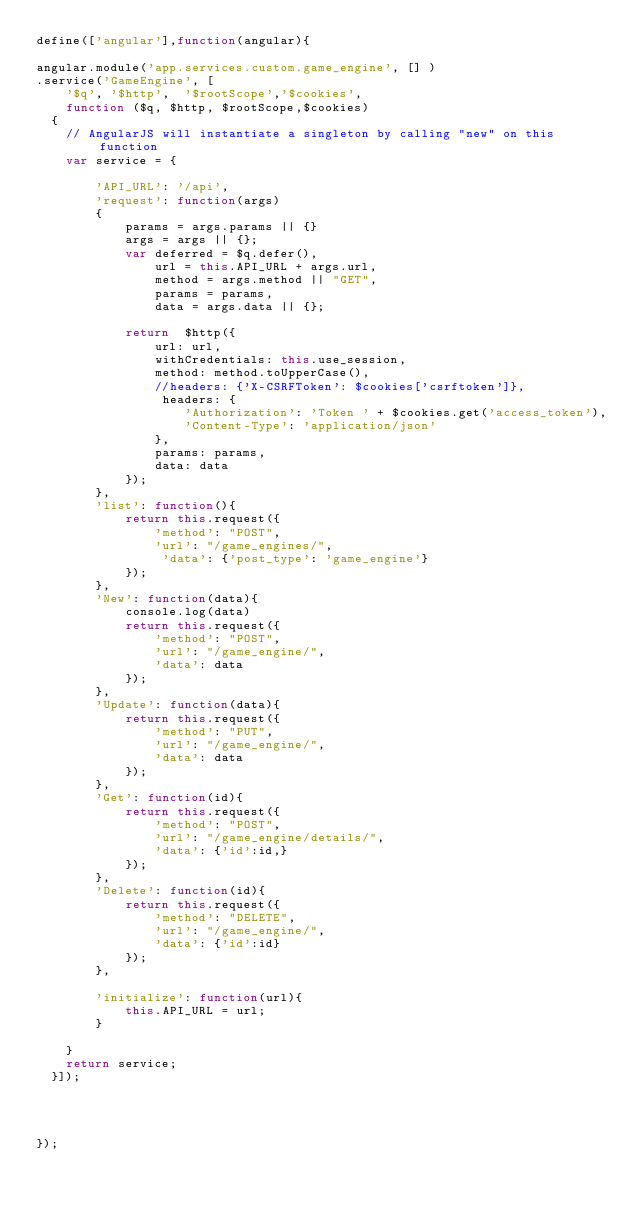Convert code to text. <code><loc_0><loc_0><loc_500><loc_500><_JavaScript_>define(['angular'],function(angular){

angular.module('app.services.custom.game_engine', [] )
.service('GameEngine', [ 
    '$q', '$http',  '$rootScope','$cookies', 
    function ($q, $http, $rootScope,$cookies) 
  {
    // AngularJS will instantiate a singleton by calling "new" on this function
    var service = {
        
        'API_URL': '/api',
        'request': function(args) 
        {
            params = args.params || {}
            args = args || {};
            var deferred = $q.defer(),
                url = this.API_URL + args.url,
                method = args.method || "GET",
                params = params,
                data = args.data || {};
            
            return  $http({
                url: url,
                withCredentials: this.use_session,
                method: method.toUpperCase(),
                //headers: {'X-CSRFToken': $cookies['csrftoken']},
                 headers: {
                    'Authorization': 'Token ' + $cookies.get('access_token'),
                    'Content-Type': 'application/json'
                },
                params: params,
                data: data
            });
        },
        'list': function(){
            return this.request({
                'method': "POST",
                'url': "/game_engines/",
                 'data': {'post_type': 'game_engine'}            
            });
        },
        'New': function(data){
            console.log(data)
            return this.request({
                'method': "POST",
                'url': "/game_engine/",
                'data': data              
            });
        },
        'Update': function(data){
            return this.request({
                'method': "PUT",
                'url': "/game_engine/",
                'data': data       
            });
        },
        'Get': function(id){
            return this.request({
                'method': "POST",
                'url': "/game_engine/details/",
                'data': {'id':id,}                 
            });
        },
        'Delete': function(id){
            return this.request({
                'method': "DELETE",
                'url': "/game_engine/", 
                'data': {'id':id}             
            });
        },
           
        'initialize': function(url){
            this.API_URL = url;         
        }

    }
    return service;
  }]);




});


</code> 